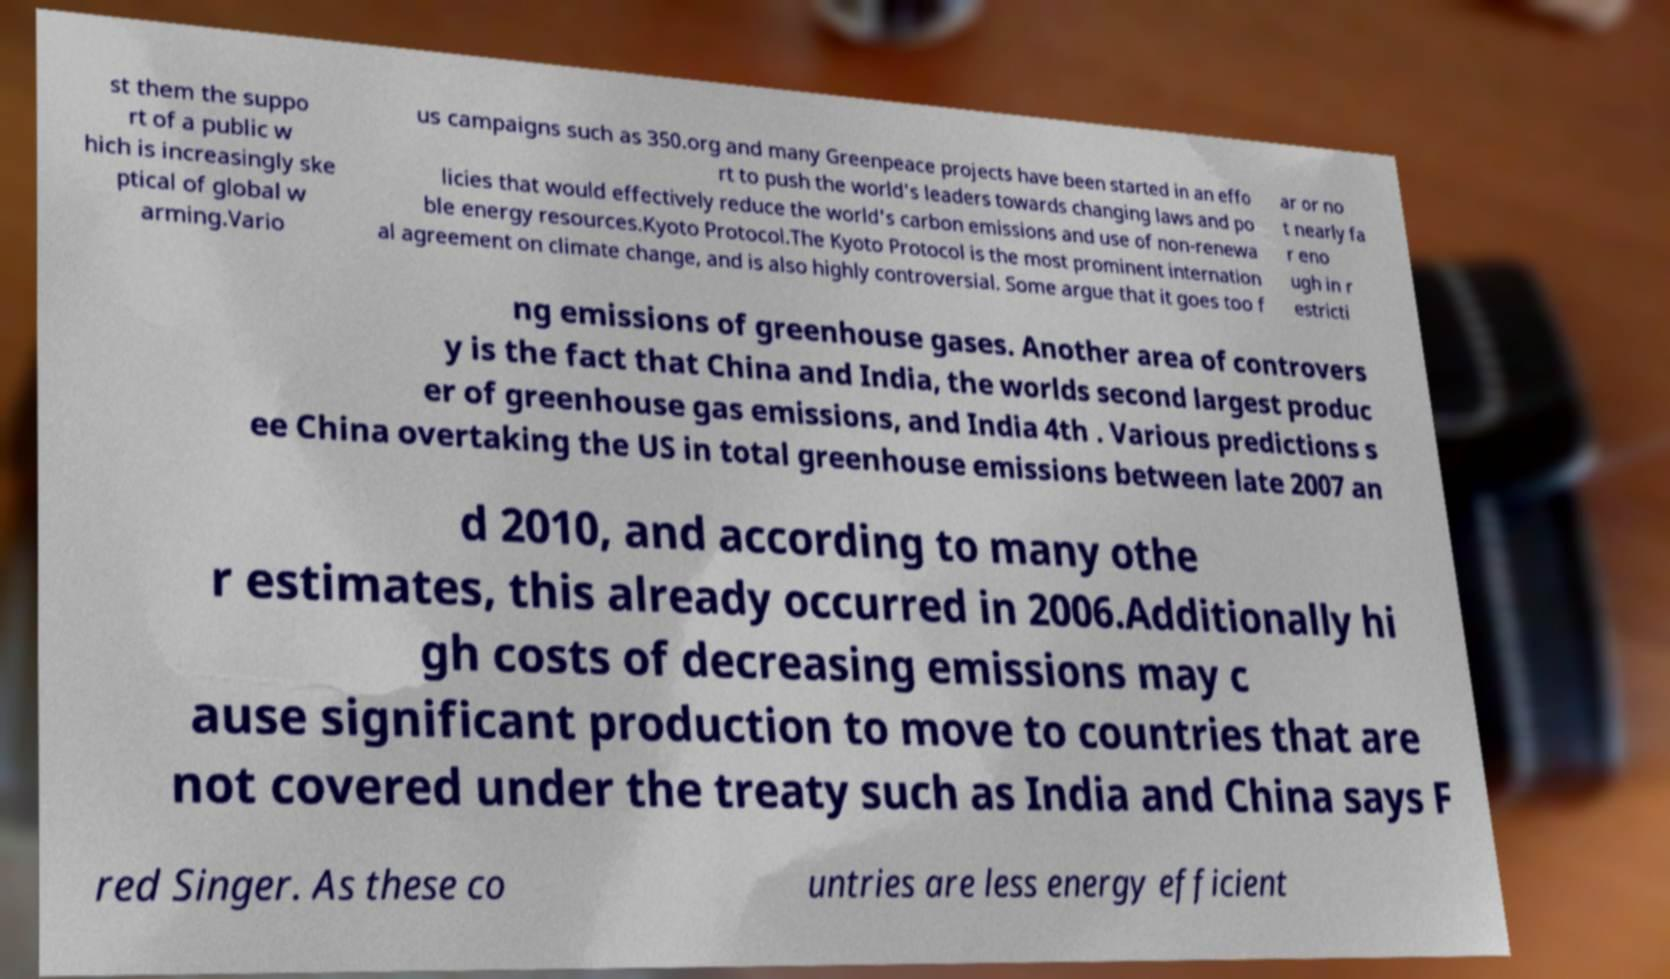Please read and relay the text visible in this image. What does it say? st them the suppo rt of a public w hich is increasingly ske ptical of global w arming.Vario us campaigns such as 350.org and many Greenpeace projects have been started in an effo rt to push the world's leaders towards changing laws and po licies that would effectively reduce the world's carbon emissions and use of non-renewa ble energy resources.Kyoto Protocol.The Kyoto Protocol is the most prominent internation al agreement on climate change, and is also highly controversial. Some argue that it goes too f ar or no t nearly fa r eno ugh in r estricti ng emissions of greenhouse gases. Another area of controvers y is the fact that China and India, the worlds second largest produc er of greenhouse gas emissions, and India 4th . Various predictions s ee China overtaking the US in total greenhouse emissions between late 2007 an d 2010, and according to many othe r estimates, this already occurred in 2006.Additionally hi gh costs of decreasing emissions may c ause significant production to move to countries that are not covered under the treaty such as India and China says F red Singer. As these co untries are less energy efficient 